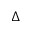Convert formula to latex. <formula><loc_0><loc_0><loc_500><loc_500>\Delta</formula> 